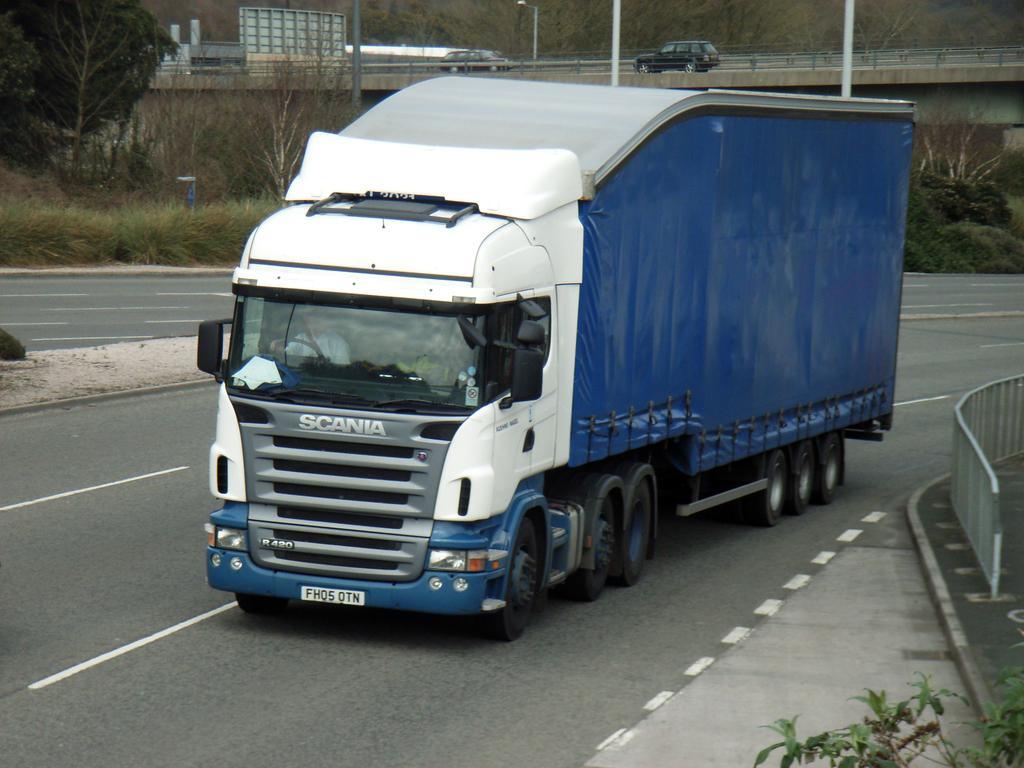How would you summarize this image in a sentence or two? In this image we can see the vehicles on the ground and we can see a fence. In the background there is a bridge and there are trees, plants and poles. 